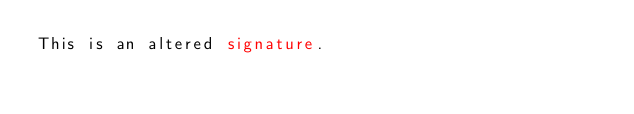Convert code to text. <code><loc_0><loc_0><loc_500><loc_500><_SML_>This is an altered signature.</code> 